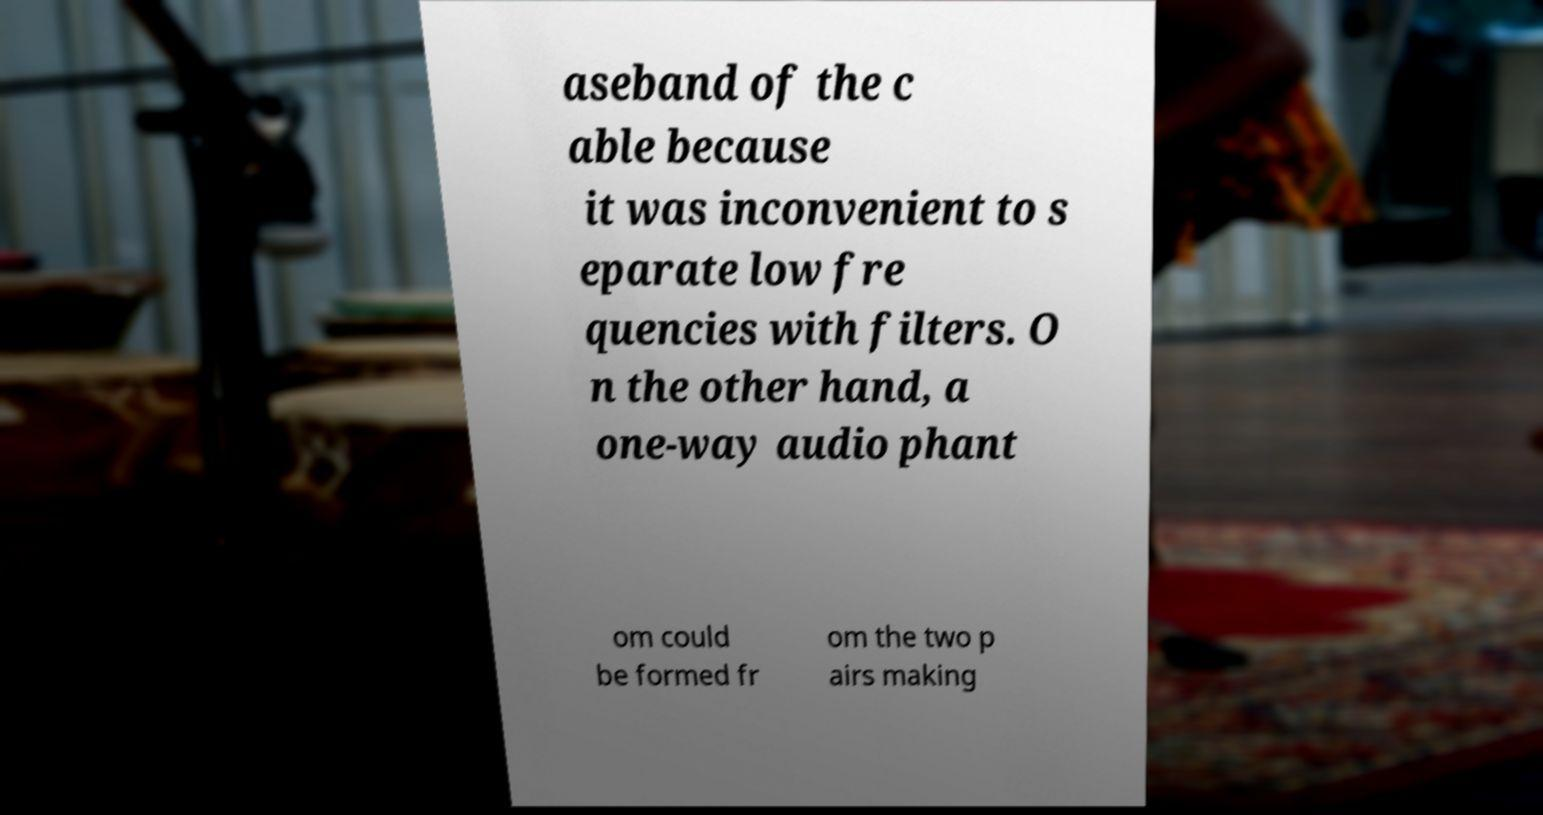Please identify and transcribe the text found in this image. aseband of the c able because it was inconvenient to s eparate low fre quencies with filters. O n the other hand, a one-way audio phant om could be formed fr om the two p airs making 